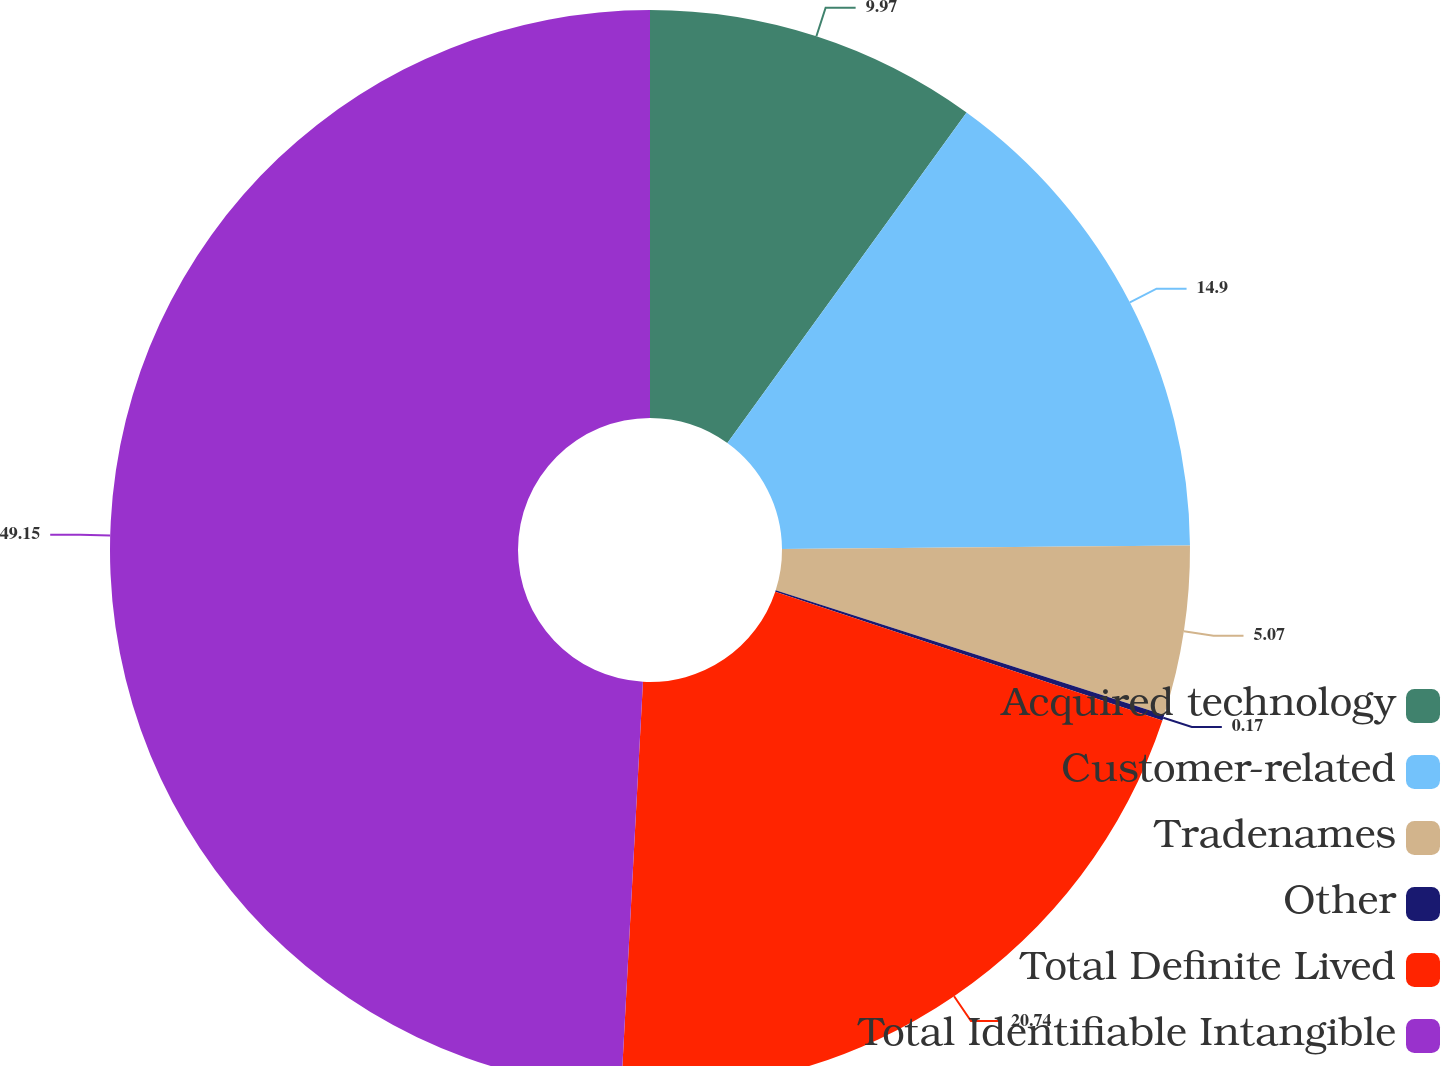<chart> <loc_0><loc_0><loc_500><loc_500><pie_chart><fcel>Acquired technology<fcel>Customer-related<fcel>Tradenames<fcel>Other<fcel>Total Definite Lived<fcel>Total Identifiable Intangible<nl><fcel>9.97%<fcel>14.9%<fcel>5.07%<fcel>0.17%<fcel>20.74%<fcel>49.15%<nl></chart> 